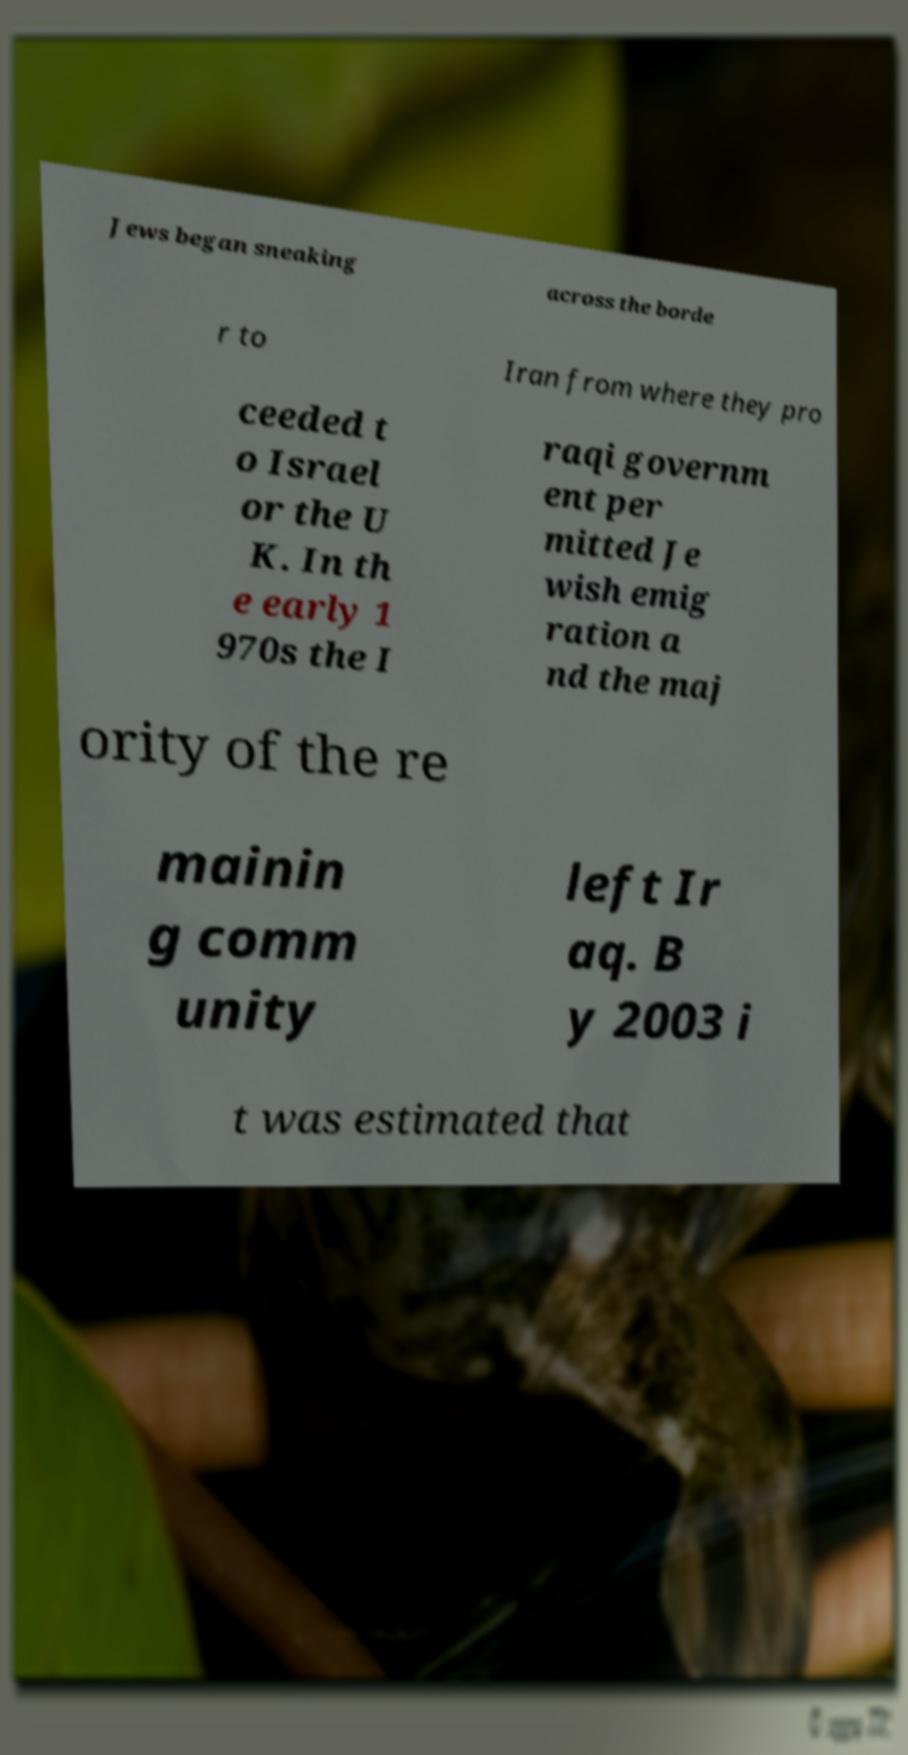I need the written content from this picture converted into text. Can you do that? Jews began sneaking across the borde r to Iran from where they pro ceeded t o Israel or the U K. In th e early 1 970s the I raqi governm ent per mitted Je wish emig ration a nd the maj ority of the re mainin g comm unity left Ir aq. B y 2003 i t was estimated that 